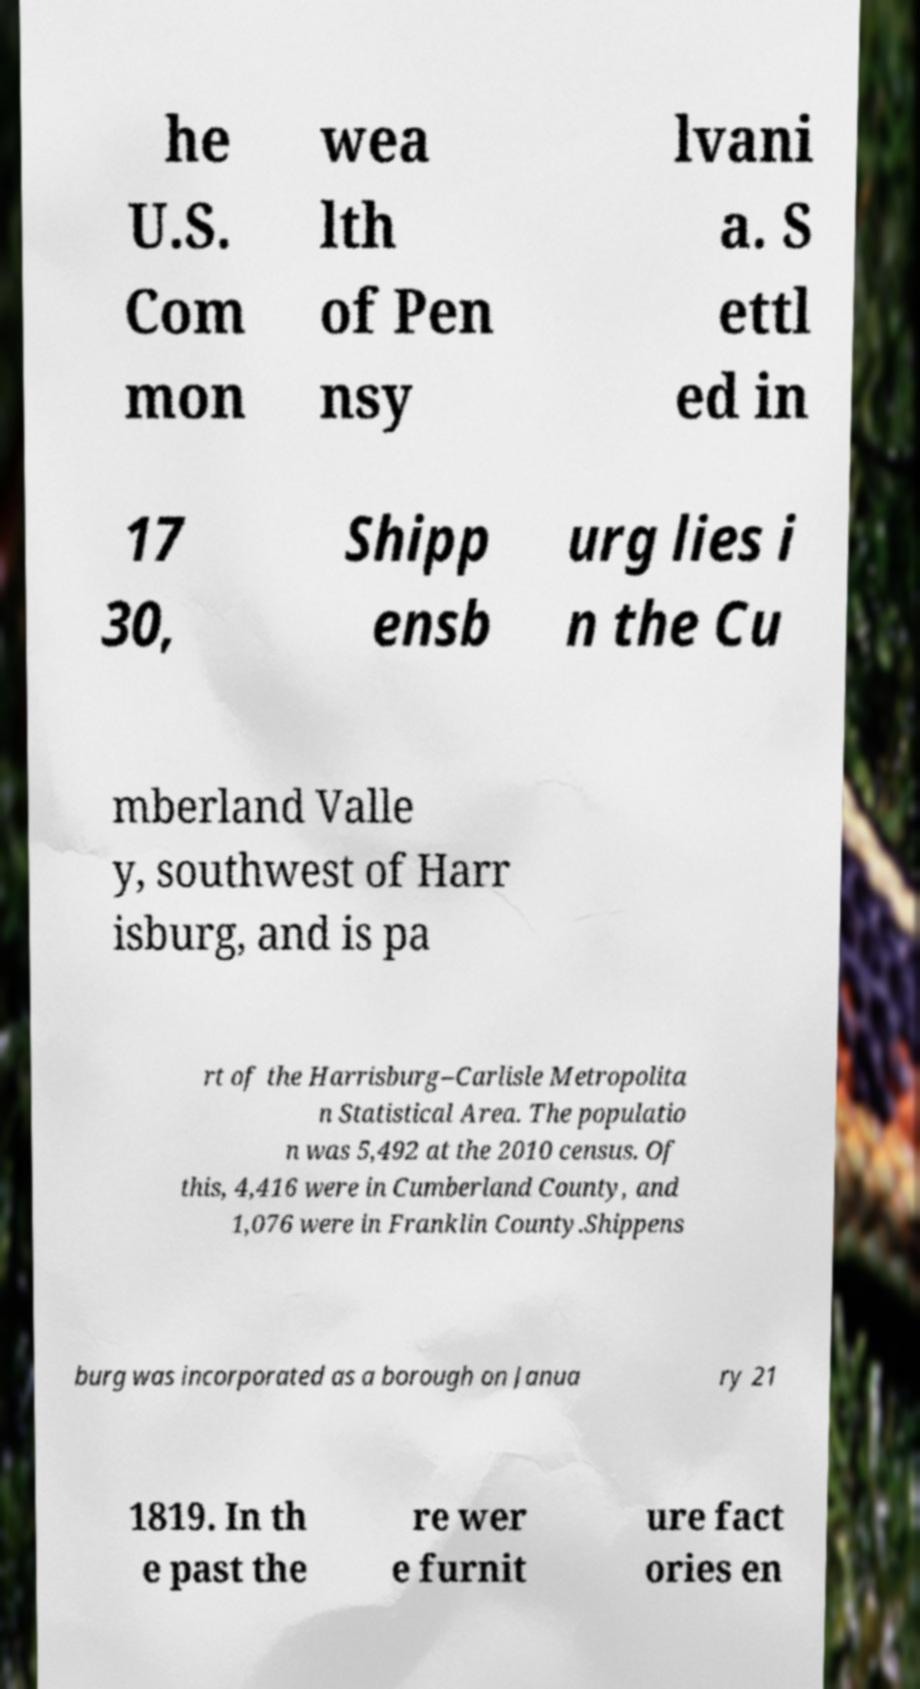Could you extract and type out the text from this image? he U.S. Com mon wea lth of Pen nsy lvani a. S ettl ed in 17 30, Shipp ensb urg lies i n the Cu mberland Valle y, southwest of Harr isburg, and is pa rt of the Harrisburg–Carlisle Metropolita n Statistical Area. The populatio n was 5,492 at the 2010 census. Of this, 4,416 were in Cumberland County, and 1,076 were in Franklin County.Shippens burg was incorporated as a borough on Janua ry 21 1819. In th e past the re wer e furnit ure fact ories en 